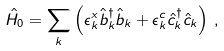Convert formula to latex. <formula><loc_0><loc_0><loc_500><loc_500>\hat { H } _ { 0 } = \sum _ { k } \left ( \epsilon ^ { x } _ { k } \hat { b } ^ { \dagger } _ { k } \hat { b } _ { k } + \epsilon ^ { c } _ { k } \hat { c } ^ { \dagger } _ { k } \hat { c } _ { k } \right ) \, ,</formula> 